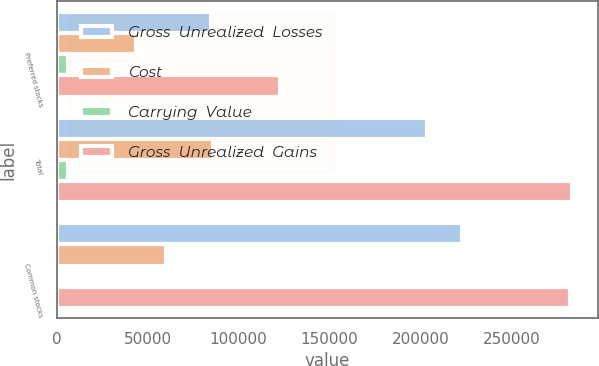<chart> <loc_0><loc_0><loc_500><loc_500><stacked_bar_chart><ecel><fcel>Preferred stocks<fcel>Total<fcel>Common stocks<nl><fcel>Gross  Unrealized  Losses<fcel>85091<fcel>203627<fcel>222671<nl><fcel>Cost<fcel>43791<fcel>86030<fcel>60102<nl><fcel>Carrying  Value<fcel>6319<fcel>6319<fcel>707<nl><fcel>Gross  Unrealized  Gains<fcel>122563<fcel>283338<fcel>282066<nl></chart> 